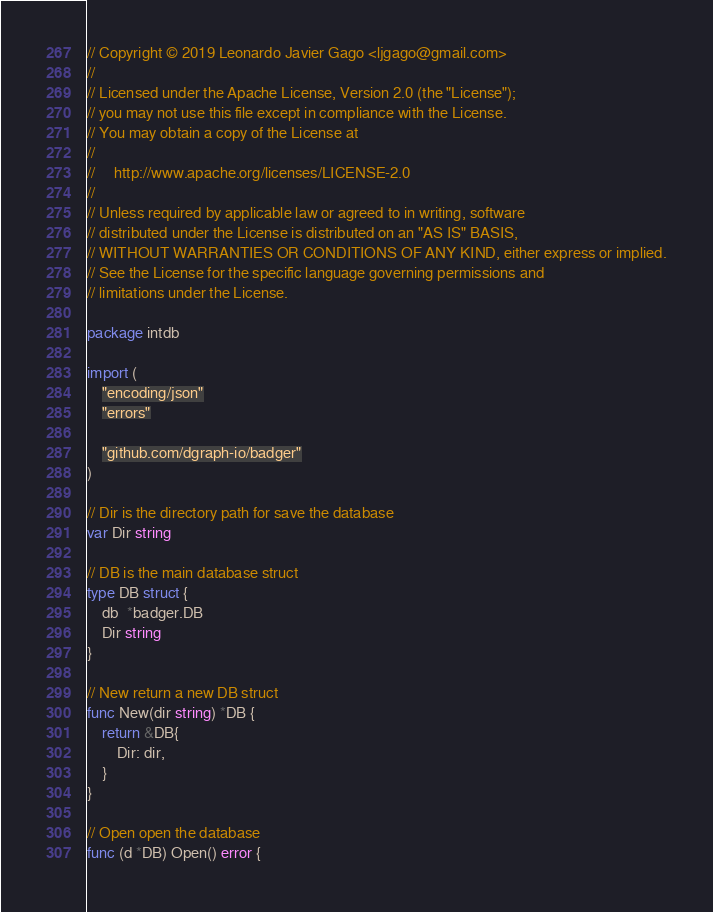Convert code to text. <code><loc_0><loc_0><loc_500><loc_500><_Go_>// Copyright © 2019 Leonardo Javier Gago <ljgago@gmail.com>
//
// Licensed under the Apache License, Version 2.0 (the "License");
// you may not use this file except in compliance with the License.
// You may obtain a copy of the License at
//
//     http://www.apache.org/licenses/LICENSE-2.0
//
// Unless required by applicable law or agreed to in writing, software
// distributed under the License is distributed on an "AS IS" BASIS,
// WITHOUT WARRANTIES OR CONDITIONS OF ANY KIND, either express or implied.
// See the License for the specific language governing permissions and
// limitations under the License.

package intdb

import (
	"encoding/json"
	"errors"

	"github.com/dgraph-io/badger"
)

// Dir is the directory path for save the database
var Dir string

// DB is the main database struct
type DB struct {
	db  *badger.DB
	Dir string
}

// New return a new DB struct
func New(dir string) *DB {
	return &DB{
		Dir: dir,
	}
}

// Open open the database
func (d *DB) Open() error {</code> 